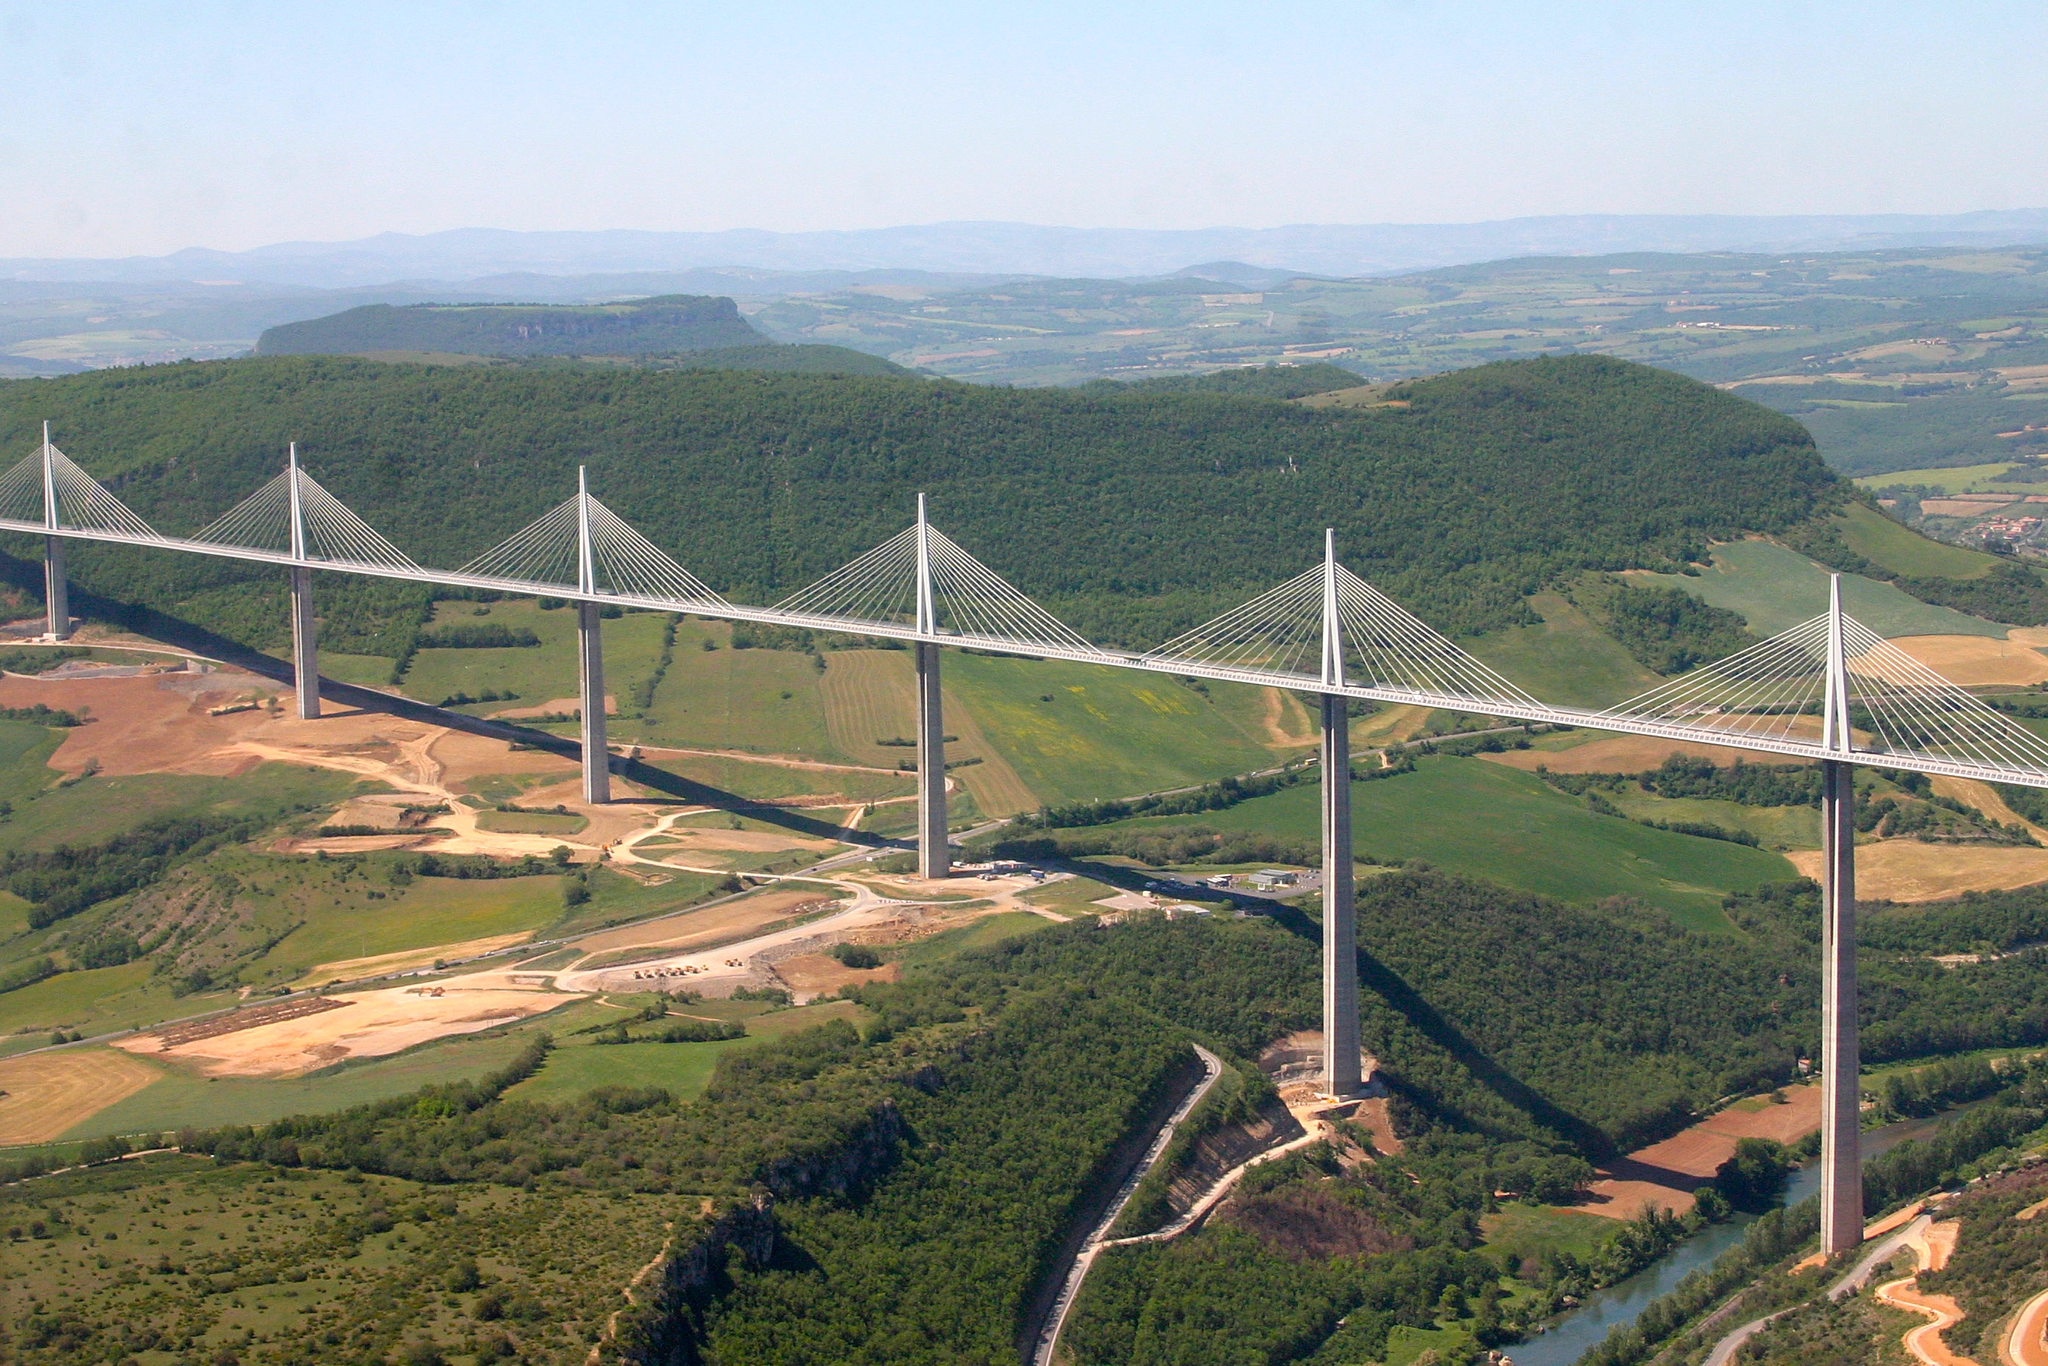Can you elaborate on the elements of the picture provided? The image showcases the impressive Millau Viaduct in southern France. This feat of modern engineering, known as the tallest bridge in the world, stands gracefully with its seven sleek, white pylons and a multitude of slender cables that connect the roadway to the towers. This cable-stayed bridge spans the Tarn River valley, known for its picturesque settings with lush green hills and fragments of farmland adding color to the landscape below. The image, an aerial view, strategically highlights the bridge's elegant alignment and the way it compliments its natural surroundings without overshadowing them. The clarity of the sky above not only emphasizes the bridge's silhouette but also illustrates the typical serene weather, providing a perfect backdrop that enhances the beauty of this architectural gem. The perspective also offers insight into the structural dynamics of the bridge and its integration into the transportation network, evidenced by visible roadways gently curving into the landscape. 